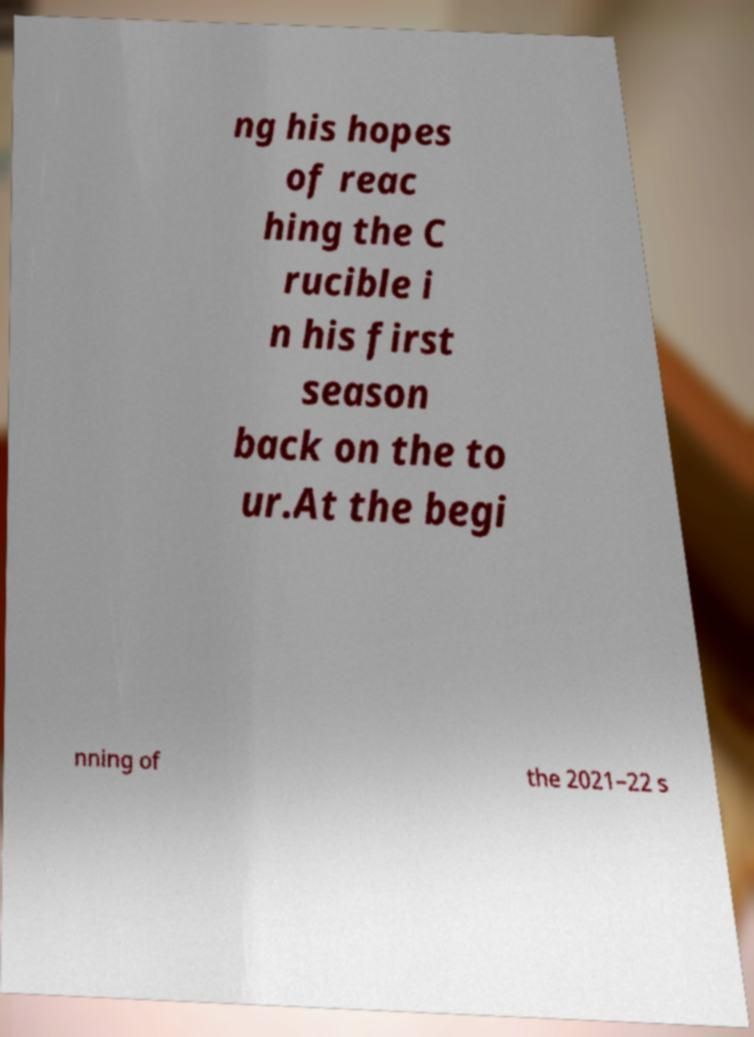Could you extract and type out the text from this image? ng his hopes of reac hing the C rucible i n his first season back on the to ur.At the begi nning of the 2021–22 s 